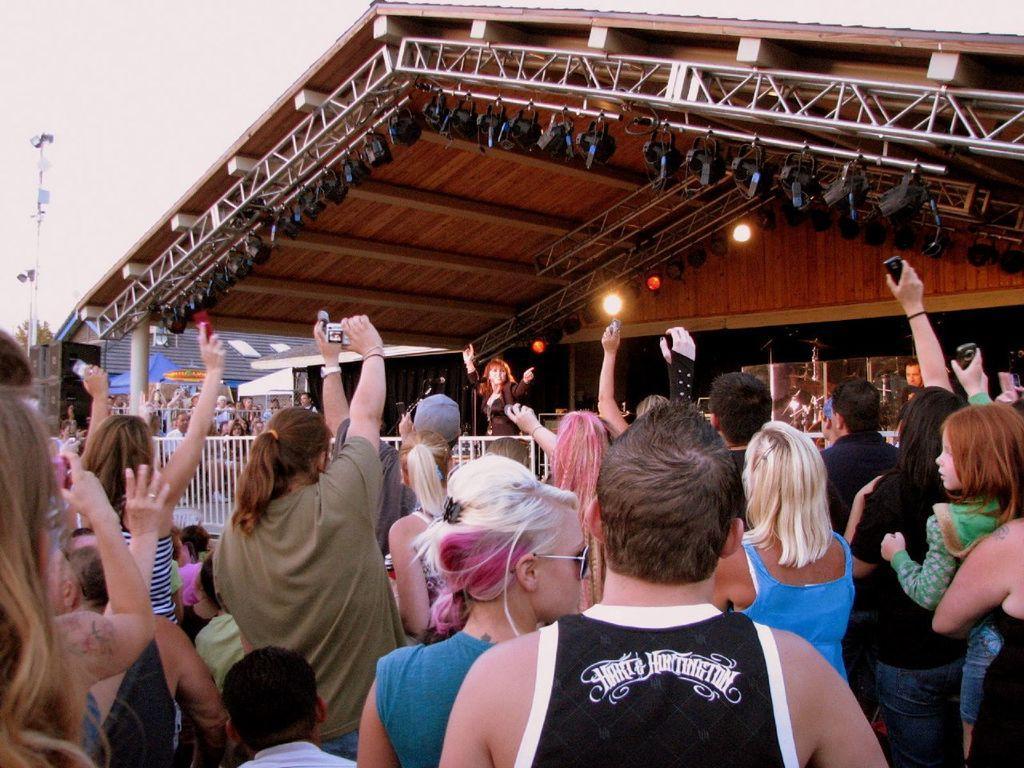In one or two sentences, can you explain what this image depicts? In this image I can see the group of people with different color dresses. I can see few people are holding the cameras. In the background I can see the railing and the sheds. I can see few lights at the top. I can see the tree, pole and the sky in the back. 